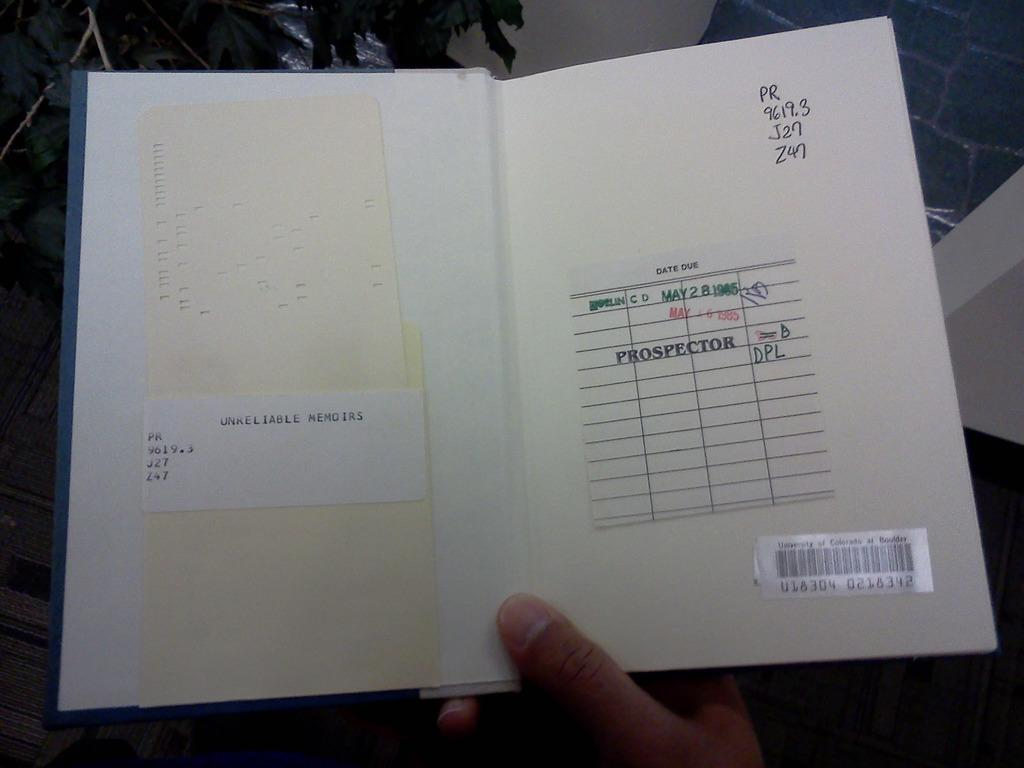Provide a one-sentence caption for the provided image. A library book is from the University of Colorado at Boulder. 